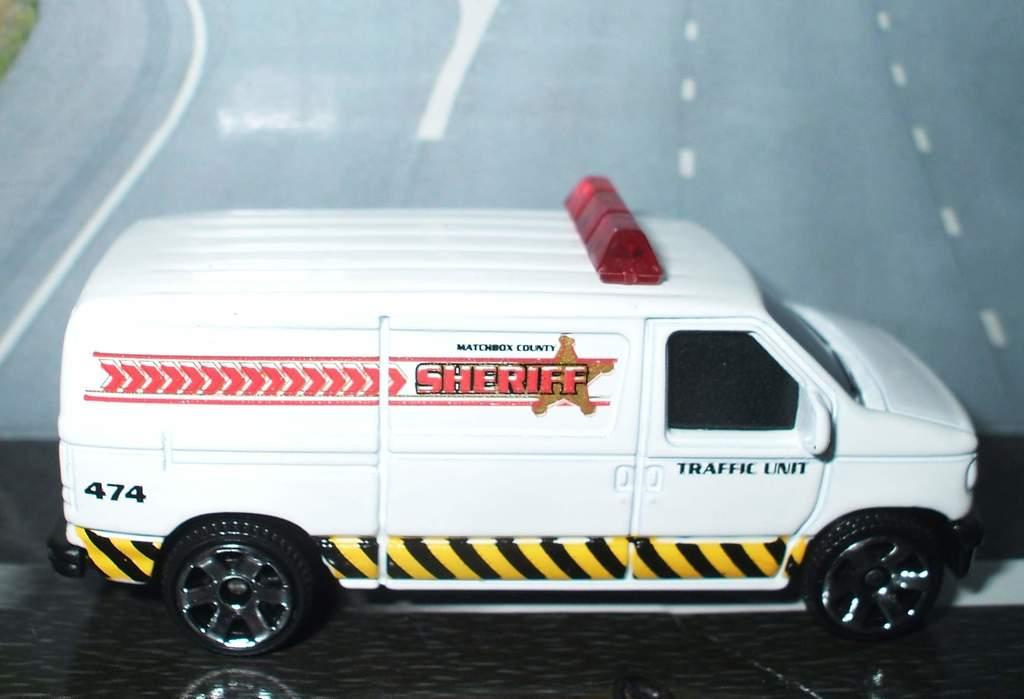<image>
Share a concise interpretation of the image provided. A small toy version of a sheriff's white van with a street backdrop. 